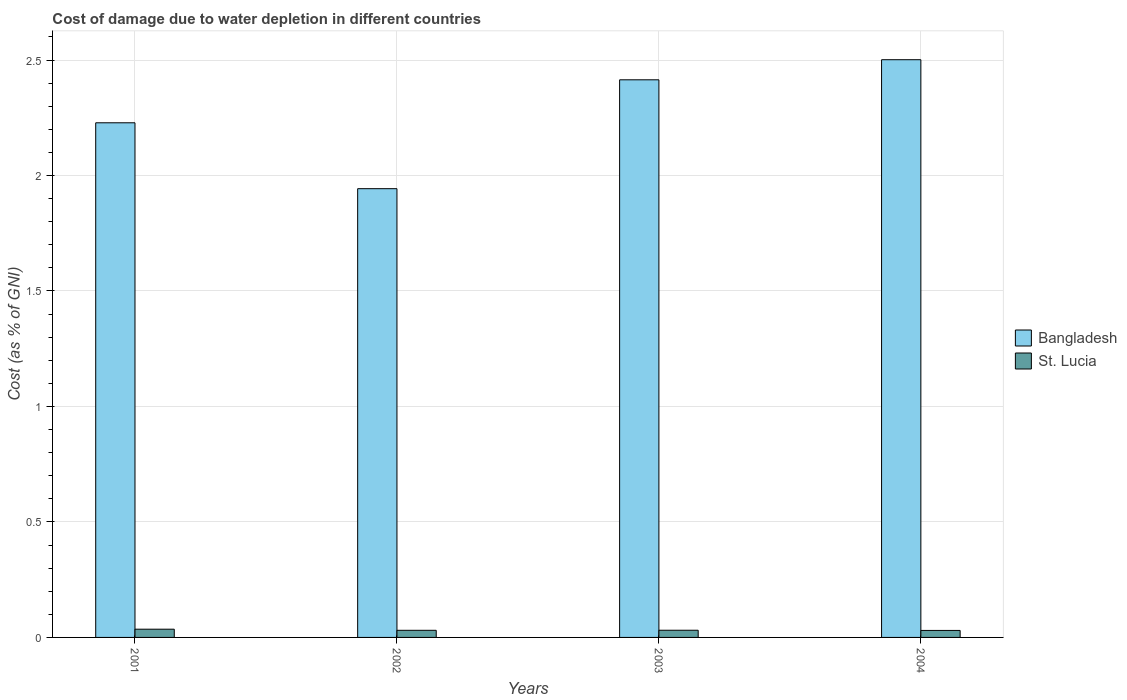Are the number of bars on each tick of the X-axis equal?
Offer a very short reply. Yes. How many bars are there on the 2nd tick from the right?
Provide a succinct answer. 2. In how many cases, is the number of bars for a given year not equal to the number of legend labels?
Provide a short and direct response. 0. What is the cost of damage caused due to water depletion in St. Lucia in 2004?
Offer a very short reply. 0.03. Across all years, what is the maximum cost of damage caused due to water depletion in St. Lucia?
Offer a very short reply. 0.04. Across all years, what is the minimum cost of damage caused due to water depletion in Bangladesh?
Provide a short and direct response. 1.94. In which year was the cost of damage caused due to water depletion in St. Lucia minimum?
Offer a terse response. 2004. What is the total cost of damage caused due to water depletion in Bangladesh in the graph?
Give a very brief answer. 9.09. What is the difference between the cost of damage caused due to water depletion in St. Lucia in 2003 and that in 2004?
Provide a short and direct response. 0. What is the difference between the cost of damage caused due to water depletion in St. Lucia in 2003 and the cost of damage caused due to water depletion in Bangladesh in 2002?
Ensure brevity in your answer.  -1.91. What is the average cost of damage caused due to water depletion in Bangladesh per year?
Make the answer very short. 2.27. In the year 2004, what is the difference between the cost of damage caused due to water depletion in St. Lucia and cost of damage caused due to water depletion in Bangladesh?
Provide a short and direct response. -2.47. What is the ratio of the cost of damage caused due to water depletion in Bangladesh in 2001 to that in 2004?
Make the answer very short. 0.89. What is the difference between the highest and the second highest cost of damage caused due to water depletion in St. Lucia?
Keep it short and to the point. 0. What is the difference between the highest and the lowest cost of damage caused due to water depletion in St. Lucia?
Give a very brief answer. 0.01. Is the sum of the cost of damage caused due to water depletion in Bangladesh in 2002 and 2004 greater than the maximum cost of damage caused due to water depletion in St. Lucia across all years?
Ensure brevity in your answer.  Yes. What does the 1st bar from the left in 2002 represents?
Keep it short and to the point. Bangladesh. What does the 2nd bar from the right in 2002 represents?
Provide a succinct answer. Bangladesh. How many years are there in the graph?
Make the answer very short. 4. What is the difference between two consecutive major ticks on the Y-axis?
Your answer should be compact. 0.5. Are the values on the major ticks of Y-axis written in scientific E-notation?
Offer a terse response. No. Does the graph contain any zero values?
Ensure brevity in your answer.  No. Where does the legend appear in the graph?
Ensure brevity in your answer.  Center right. How many legend labels are there?
Make the answer very short. 2. What is the title of the graph?
Ensure brevity in your answer.  Cost of damage due to water depletion in different countries. Does "Tunisia" appear as one of the legend labels in the graph?
Keep it short and to the point. No. What is the label or title of the Y-axis?
Provide a short and direct response. Cost (as % of GNI). What is the Cost (as % of GNI) of Bangladesh in 2001?
Keep it short and to the point. 2.23. What is the Cost (as % of GNI) in St. Lucia in 2001?
Offer a very short reply. 0.04. What is the Cost (as % of GNI) of Bangladesh in 2002?
Offer a terse response. 1.94. What is the Cost (as % of GNI) of St. Lucia in 2002?
Make the answer very short. 0.03. What is the Cost (as % of GNI) of Bangladesh in 2003?
Keep it short and to the point. 2.41. What is the Cost (as % of GNI) in St. Lucia in 2003?
Your answer should be very brief. 0.03. What is the Cost (as % of GNI) of Bangladesh in 2004?
Your answer should be very brief. 2.5. What is the Cost (as % of GNI) in St. Lucia in 2004?
Provide a short and direct response. 0.03. Across all years, what is the maximum Cost (as % of GNI) of Bangladesh?
Keep it short and to the point. 2.5. Across all years, what is the maximum Cost (as % of GNI) of St. Lucia?
Make the answer very short. 0.04. Across all years, what is the minimum Cost (as % of GNI) of Bangladesh?
Ensure brevity in your answer.  1.94. Across all years, what is the minimum Cost (as % of GNI) of St. Lucia?
Ensure brevity in your answer.  0.03. What is the total Cost (as % of GNI) of Bangladesh in the graph?
Keep it short and to the point. 9.09. What is the total Cost (as % of GNI) of St. Lucia in the graph?
Your answer should be compact. 0.13. What is the difference between the Cost (as % of GNI) in Bangladesh in 2001 and that in 2002?
Ensure brevity in your answer.  0.29. What is the difference between the Cost (as % of GNI) of St. Lucia in 2001 and that in 2002?
Make the answer very short. 0. What is the difference between the Cost (as % of GNI) of Bangladesh in 2001 and that in 2003?
Give a very brief answer. -0.19. What is the difference between the Cost (as % of GNI) in St. Lucia in 2001 and that in 2003?
Offer a very short reply. 0. What is the difference between the Cost (as % of GNI) of Bangladesh in 2001 and that in 2004?
Your answer should be compact. -0.27. What is the difference between the Cost (as % of GNI) of St. Lucia in 2001 and that in 2004?
Offer a terse response. 0.01. What is the difference between the Cost (as % of GNI) in Bangladesh in 2002 and that in 2003?
Offer a terse response. -0.47. What is the difference between the Cost (as % of GNI) of St. Lucia in 2002 and that in 2003?
Your answer should be compact. -0. What is the difference between the Cost (as % of GNI) of Bangladesh in 2002 and that in 2004?
Provide a succinct answer. -0.56. What is the difference between the Cost (as % of GNI) of St. Lucia in 2002 and that in 2004?
Make the answer very short. 0. What is the difference between the Cost (as % of GNI) of Bangladesh in 2003 and that in 2004?
Provide a short and direct response. -0.09. What is the difference between the Cost (as % of GNI) in St. Lucia in 2003 and that in 2004?
Keep it short and to the point. 0. What is the difference between the Cost (as % of GNI) in Bangladesh in 2001 and the Cost (as % of GNI) in St. Lucia in 2002?
Give a very brief answer. 2.2. What is the difference between the Cost (as % of GNI) of Bangladesh in 2001 and the Cost (as % of GNI) of St. Lucia in 2003?
Your answer should be compact. 2.2. What is the difference between the Cost (as % of GNI) of Bangladesh in 2001 and the Cost (as % of GNI) of St. Lucia in 2004?
Give a very brief answer. 2.2. What is the difference between the Cost (as % of GNI) of Bangladesh in 2002 and the Cost (as % of GNI) of St. Lucia in 2003?
Offer a terse response. 1.91. What is the difference between the Cost (as % of GNI) of Bangladesh in 2002 and the Cost (as % of GNI) of St. Lucia in 2004?
Keep it short and to the point. 1.91. What is the difference between the Cost (as % of GNI) in Bangladesh in 2003 and the Cost (as % of GNI) in St. Lucia in 2004?
Your answer should be very brief. 2.38. What is the average Cost (as % of GNI) in Bangladesh per year?
Provide a short and direct response. 2.27. What is the average Cost (as % of GNI) of St. Lucia per year?
Provide a succinct answer. 0.03. In the year 2001, what is the difference between the Cost (as % of GNI) in Bangladesh and Cost (as % of GNI) in St. Lucia?
Offer a very short reply. 2.19. In the year 2002, what is the difference between the Cost (as % of GNI) of Bangladesh and Cost (as % of GNI) of St. Lucia?
Your answer should be very brief. 1.91. In the year 2003, what is the difference between the Cost (as % of GNI) in Bangladesh and Cost (as % of GNI) in St. Lucia?
Provide a short and direct response. 2.38. In the year 2004, what is the difference between the Cost (as % of GNI) in Bangladesh and Cost (as % of GNI) in St. Lucia?
Keep it short and to the point. 2.47. What is the ratio of the Cost (as % of GNI) of Bangladesh in 2001 to that in 2002?
Offer a terse response. 1.15. What is the ratio of the Cost (as % of GNI) of St. Lucia in 2001 to that in 2002?
Offer a terse response. 1.15. What is the ratio of the Cost (as % of GNI) in Bangladesh in 2001 to that in 2003?
Provide a short and direct response. 0.92. What is the ratio of the Cost (as % of GNI) in St. Lucia in 2001 to that in 2003?
Offer a very short reply. 1.14. What is the ratio of the Cost (as % of GNI) of Bangladesh in 2001 to that in 2004?
Keep it short and to the point. 0.89. What is the ratio of the Cost (as % of GNI) in St. Lucia in 2001 to that in 2004?
Provide a short and direct response. 1.18. What is the ratio of the Cost (as % of GNI) in Bangladesh in 2002 to that in 2003?
Ensure brevity in your answer.  0.8. What is the ratio of the Cost (as % of GNI) in Bangladesh in 2002 to that in 2004?
Your answer should be compact. 0.78. What is the ratio of the Cost (as % of GNI) of St. Lucia in 2002 to that in 2004?
Ensure brevity in your answer.  1.02. What is the ratio of the Cost (as % of GNI) in Bangladesh in 2003 to that in 2004?
Make the answer very short. 0.97. What is the ratio of the Cost (as % of GNI) of St. Lucia in 2003 to that in 2004?
Offer a very short reply. 1.03. What is the difference between the highest and the second highest Cost (as % of GNI) in Bangladesh?
Give a very brief answer. 0.09. What is the difference between the highest and the second highest Cost (as % of GNI) in St. Lucia?
Keep it short and to the point. 0. What is the difference between the highest and the lowest Cost (as % of GNI) of Bangladesh?
Your response must be concise. 0.56. What is the difference between the highest and the lowest Cost (as % of GNI) in St. Lucia?
Offer a terse response. 0.01. 